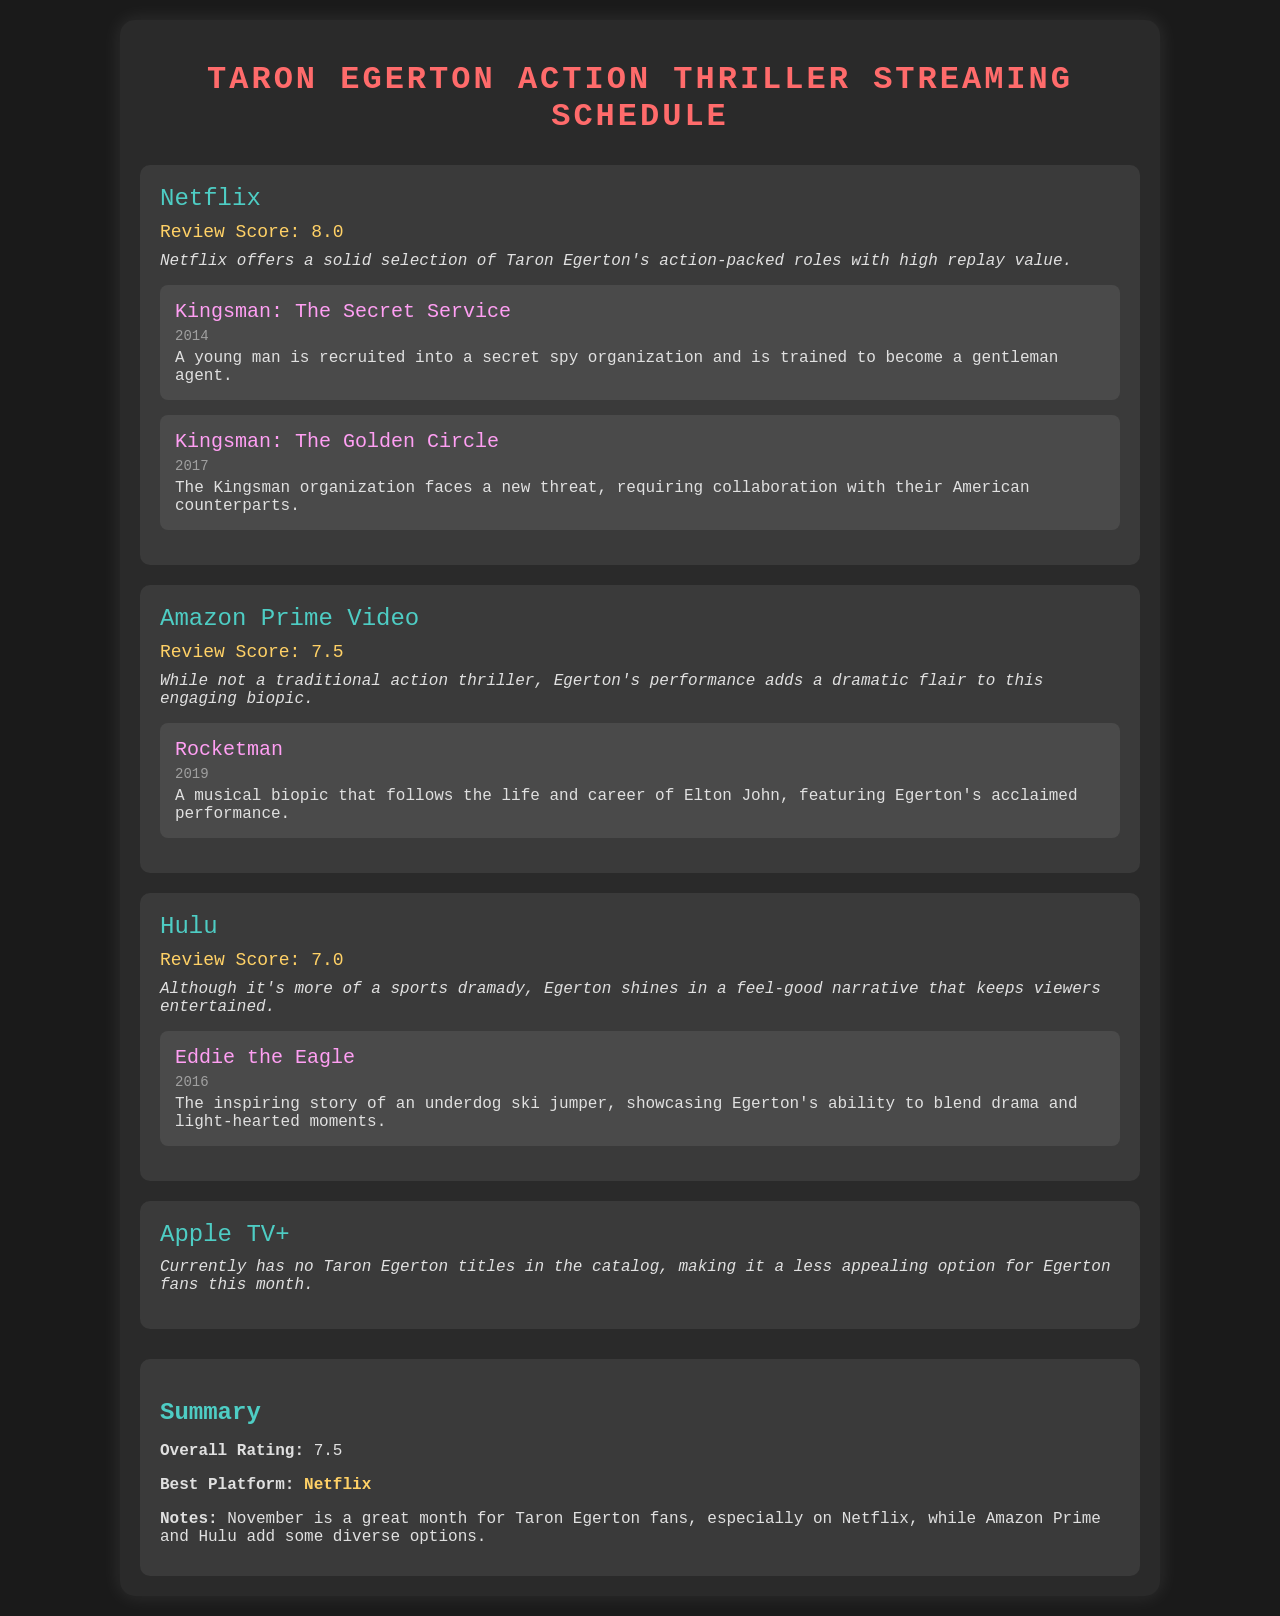What is the review score for Netflix? The review score for Netflix is mentioned as 8.0 in the document.
Answer: 8.0 Which film featuring Taron Egerton was released in 2016? The document lists "Eddie the Eagle" as a film featuring Taron Egerton released in 2016.
Answer: Eddie the Eagle What is the best platform for Taron Egerton films this month? According to the summary, Netflix is mentioned as the best platform for Taron Egerton films this month.
Answer: Netflix How many Taron Egerton titles are available on Apple TV+? The document states that Apple TV+ currently has no Taron Egerton titles in the catalog.
Answer: None What genre is "Rocketman" described as in the document? The comment for Amazon Prime Video describes "Rocketman" as a musical biopic.
Answer: Musical biopic Why might Hulu be considered less appealing for Taron Egerton fans? The document mentions that Hulu offers a sports dramady that may not align with action thrillers, making it less appealing for Egerton fans.
Answer: Less appealing for action thrillers What is the overall rating for Taron Egerton films this month? The summary provides the overall rating as 7.5 for Taron Egerton films this month.
Answer: 7.5 List the films available on Netflix. The films available on Netflix according to the document are "Kingsman: The Secret Service" and "Kingsman: The Golden Circle."
Answer: Kingsman: The Secret Service, Kingsman: The Golden Circle What is the review score for Amazon Prime Video? The review score for Amazon Prime Video is mentioned as 7.5 in the document.
Answer: 7.5 